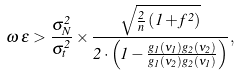Convert formula to latex. <formula><loc_0><loc_0><loc_500><loc_500>\omega \, \epsilon > \frac { \sigma _ { N } ^ { 2 } } { \sigma _ { t } ^ { 2 } } \times \frac { \sqrt { \frac { 2 } { n } \left ( 1 + f ^ { 2 } \right ) } } { 2 \cdot \left ( 1 - \frac { g _ { 1 } ( \nu _ { 1 } ) g _ { 2 } ( \nu _ { 2 } ) } { g _ { 1 } ( \nu _ { 2 } ) g _ { 2 } ( \nu _ { 1 } ) } \right ) } ,</formula> 